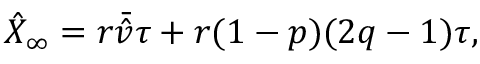<formula> <loc_0><loc_0><loc_500><loc_500>\hat { X } _ { \infty } = r \bar { \hat { v } } \tau + r ( 1 - p ) ( 2 q - 1 ) \tau ,</formula> 